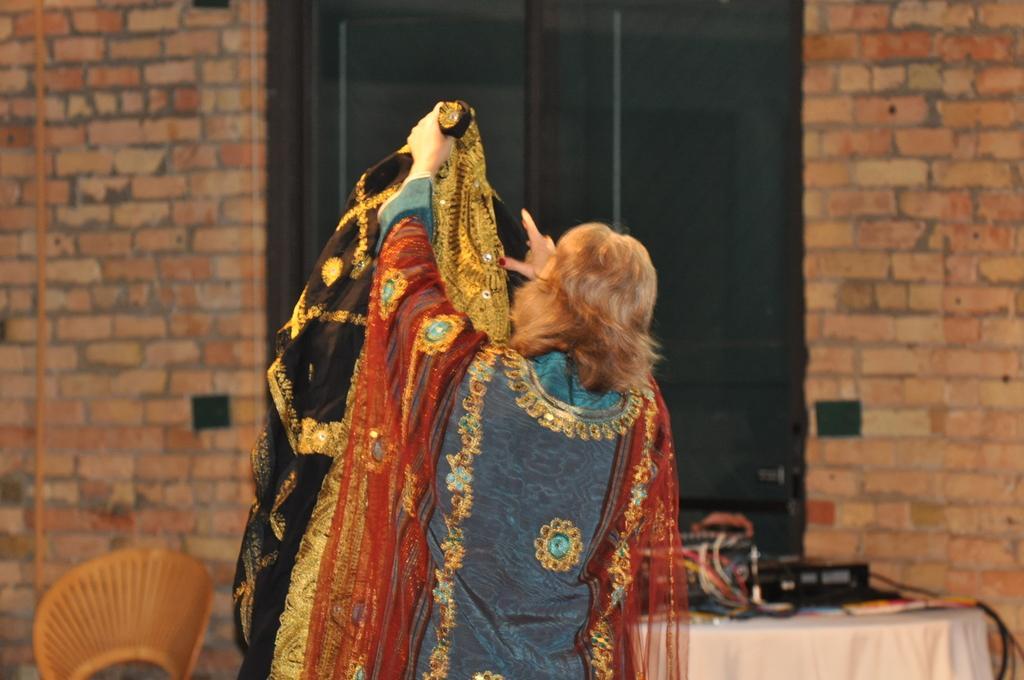Can you describe this image briefly? Here we can see a person holding a cloth. This is a table. On the table there is a cloth, cables, and a device. In the background we can see a wall. 